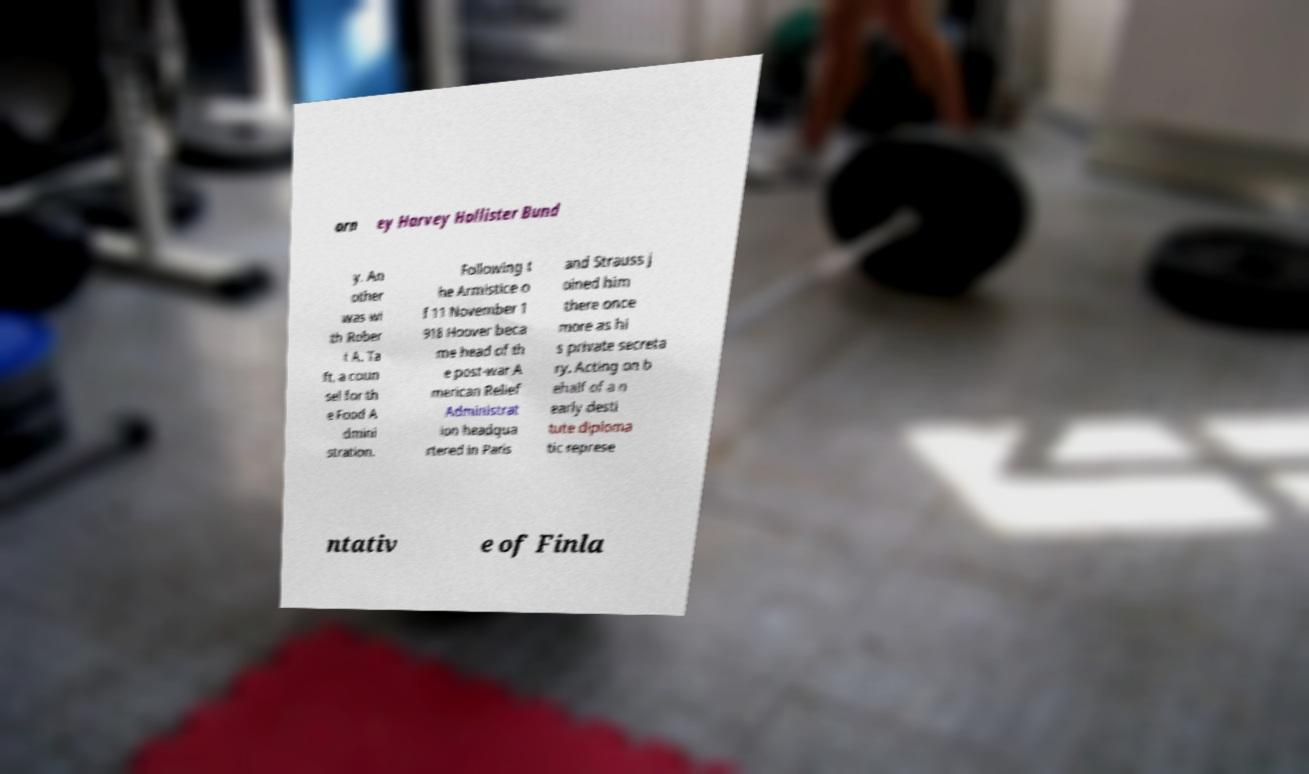Can you read and provide the text displayed in the image?This photo seems to have some interesting text. Can you extract and type it out for me? orn ey Harvey Hollister Bund y. An other was wi th Rober t A. Ta ft, a coun sel for th e Food A dmini stration. Following t he Armistice o f 11 November 1 918 Hoover beca me head of th e post-war A merican Relief Administrat ion headqua rtered in Paris and Strauss j oined him there once more as hi s private secreta ry. Acting on b ehalf of a n early desti tute diploma tic represe ntativ e of Finla 